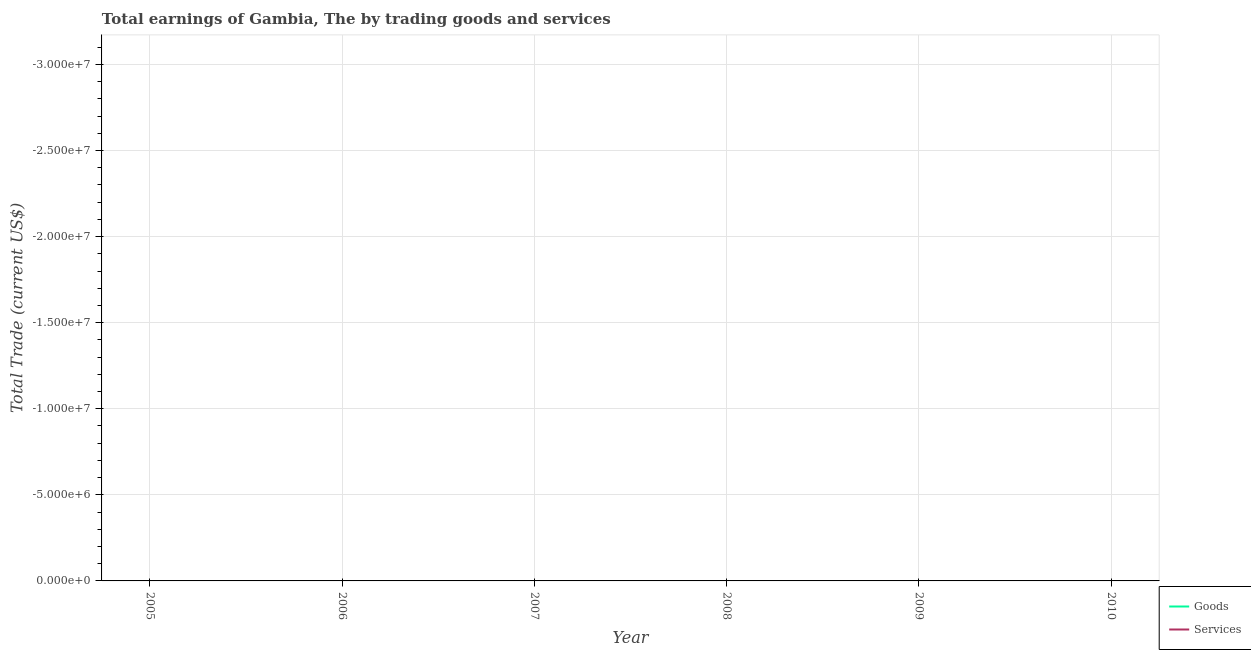How many different coloured lines are there?
Your answer should be very brief. 0. Does the line corresponding to amount earned by trading goods intersect with the line corresponding to amount earned by trading services?
Ensure brevity in your answer.  Yes. Is the number of lines equal to the number of legend labels?
Provide a short and direct response. No. What is the difference between the amount earned by trading services in 2007 and the amount earned by trading goods in 2010?
Offer a very short reply. 0. In how many years, is the amount earned by trading goods greater than -10000000 US$?
Offer a very short reply. 0. Does the amount earned by trading services monotonically increase over the years?
Provide a short and direct response. No. Is the amount earned by trading goods strictly less than the amount earned by trading services over the years?
Give a very brief answer. No. How many years are there in the graph?
Your answer should be compact. 6. Are the values on the major ticks of Y-axis written in scientific E-notation?
Offer a terse response. Yes. Does the graph contain any zero values?
Offer a very short reply. Yes. Does the graph contain grids?
Keep it short and to the point. Yes. Where does the legend appear in the graph?
Provide a succinct answer. Bottom right. What is the title of the graph?
Your answer should be compact. Total earnings of Gambia, The by trading goods and services. What is the label or title of the Y-axis?
Offer a terse response. Total Trade (current US$). What is the Total Trade (current US$) in Goods in 2005?
Provide a short and direct response. 0. What is the Total Trade (current US$) in Services in 2005?
Ensure brevity in your answer.  0. What is the Total Trade (current US$) of Goods in 2006?
Your answer should be very brief. 0. What is the Total Trade (current US$) of Services in 2006?
Make the answer very short. 0. What is the Total Trade (current US$) of Goods in 2007?
Your answer should be very brief. 0. What is the Total Trade (current US$) of Services in 2007?
Your response must be concise. 0. What is the Total Trade (current US$) of Services in 2008?
Your answer should be compact. 0. What is the Total Trade (current US$) in Services in 2009?
Provide a succinct answer. 0. What is the Total Trade (current US$) of Services in 2010?
Keep it short and to the point. 0. What is the total Total Trade (current US$) of Goods in the graph?
Ensure brevity in your answer.  0. What is the average Total Trade (current US$) of Goods per year?
Keep it short and to the point. 0. What is the average Total Trade (current US$) of Services per year?
Provide a short and direct response. 0. 